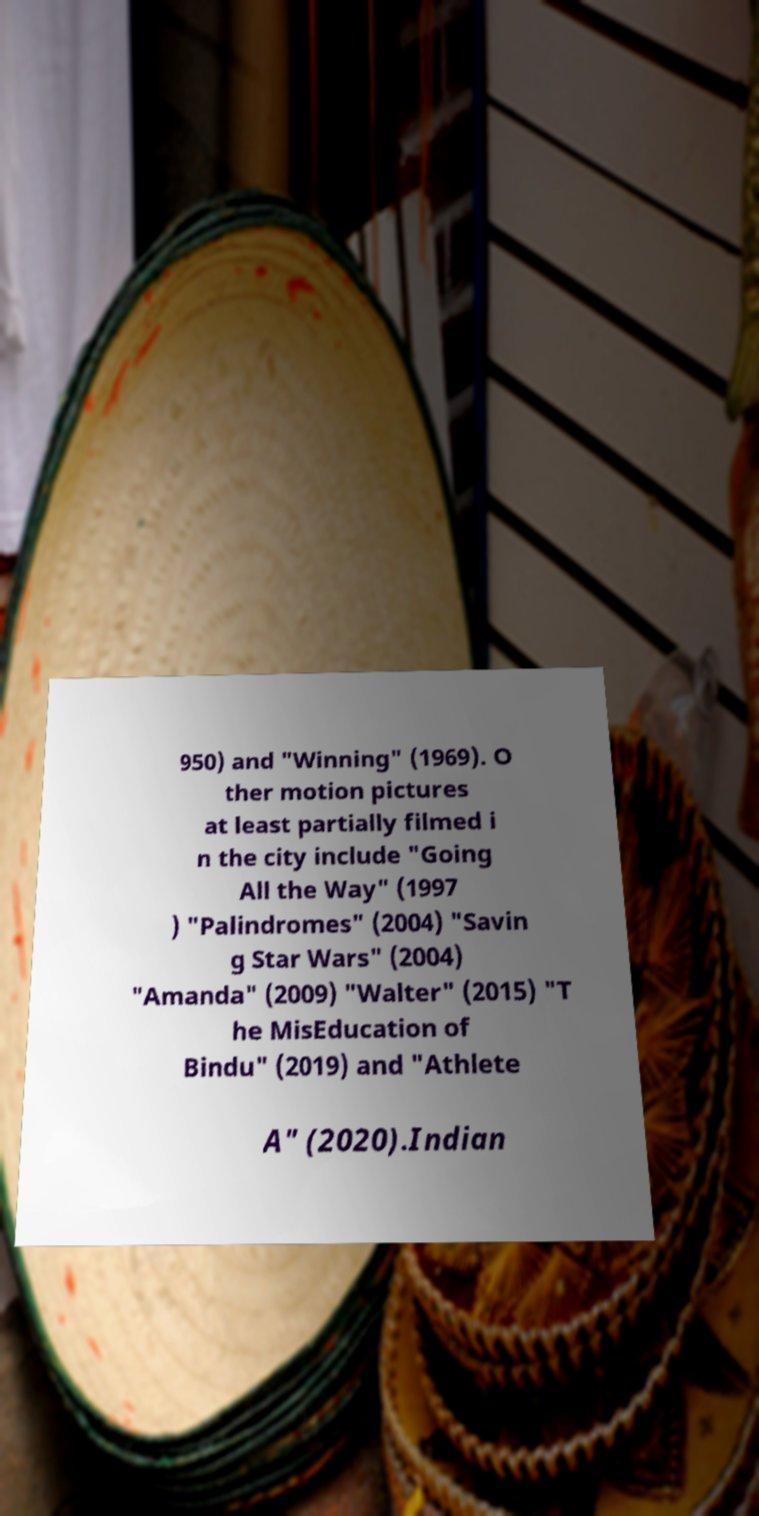Could you extract and type out the text from this image? 950) and "Winning" (1969). O ther motion pictures at least partially filmed i n the city include "Going All the Way" (1997 ) "Palindromes" (2004) "Savin g Star Wars" (2004) "Amanda" (2009) "Walter" (2015) "T he MisEducation of Bindu" (2019) and "Athlete A" (2020).Indian 